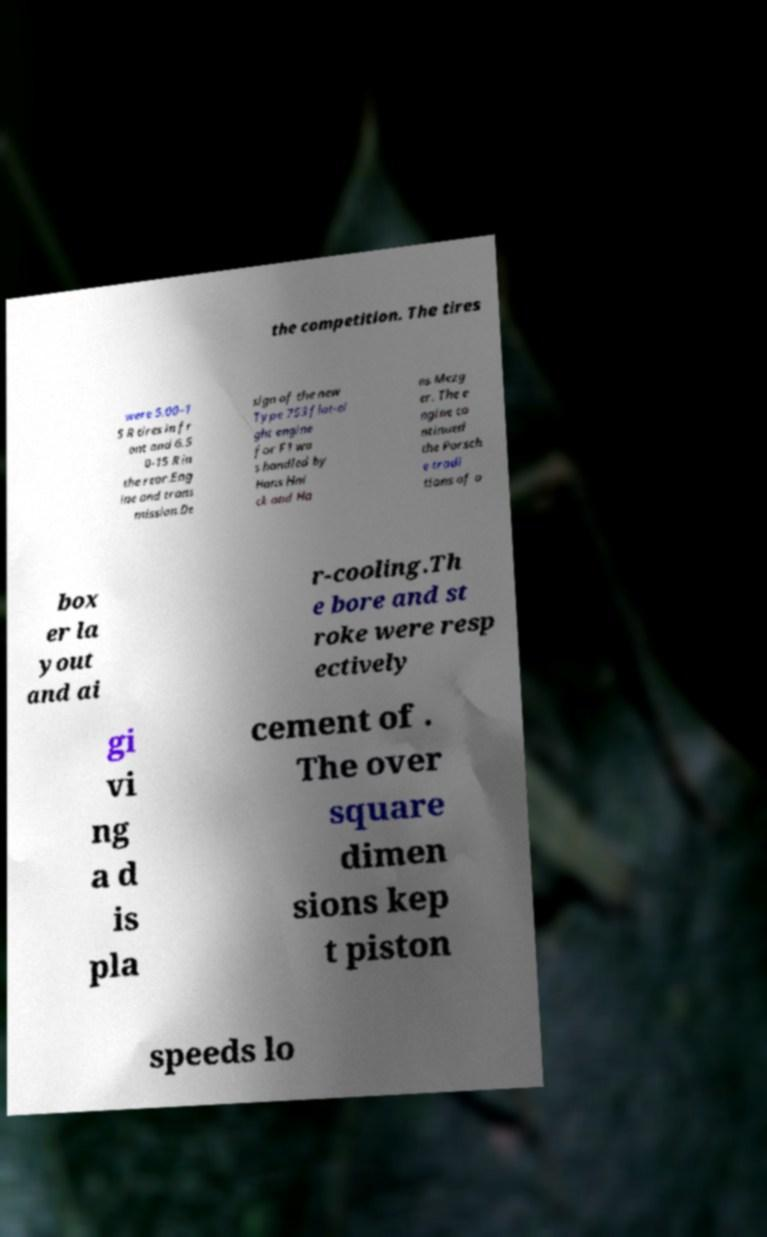Please read and relay the text visible in this image. What does it say? the competition. The tires were 5.00–1 5 R tires in fr ont and 6.5 0-15 R in the rear.Eng ine and trans mission.De sign of the new Type 753 flat-ei ght engine for F1 wa s handled by Hans Hni ck and Ha ns Mezg er. The e ngine co ntinued the Porsch e tradi tions of a box er la yout and ai r-cooling.Th e bore and st roke were resp ectively gi vi ng a d is pla cement of . The over square dimen sions kep t piston speeds lo 